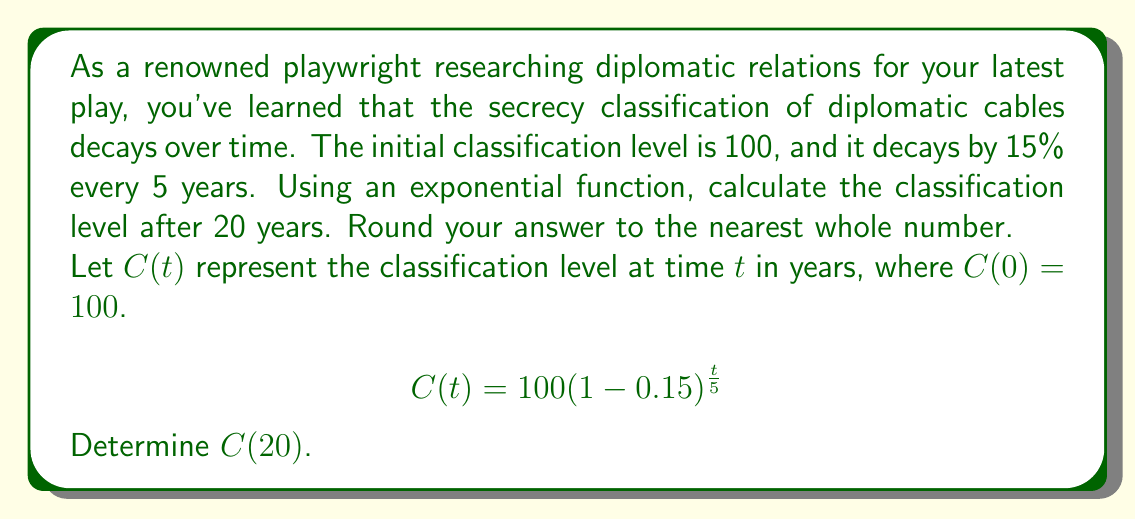Can you answer this question? To solve this problem, we'll follow these steps:

1) We're given the exponential decay function:
   $$C(t) = 100(1-0.15)^{\frac{t}{5}}$$

2) We need to calculate $C(20)$, so we'll substitute $t=20$ into the equation:
   $$C(20) = 100(1-0.15)^{\frac{20}{5}}$$

3) Simplify the exponent:
   $$C(20) = 100(1-0.15)^4$$

4) Simplify inside the parentheses:
   $$C(20) = 100(0.85)^4$$

5) Calculate the power:
   $$C(20) = 100(0.5220625)$$

6) Multiply:
   $$C(20) = 52.20625$$

7) Round to the nearest whole number:
   $$C(20) \approx 52$$

Therefore, after 20 years, the classification level will be approximately 52.
Answer: 52 